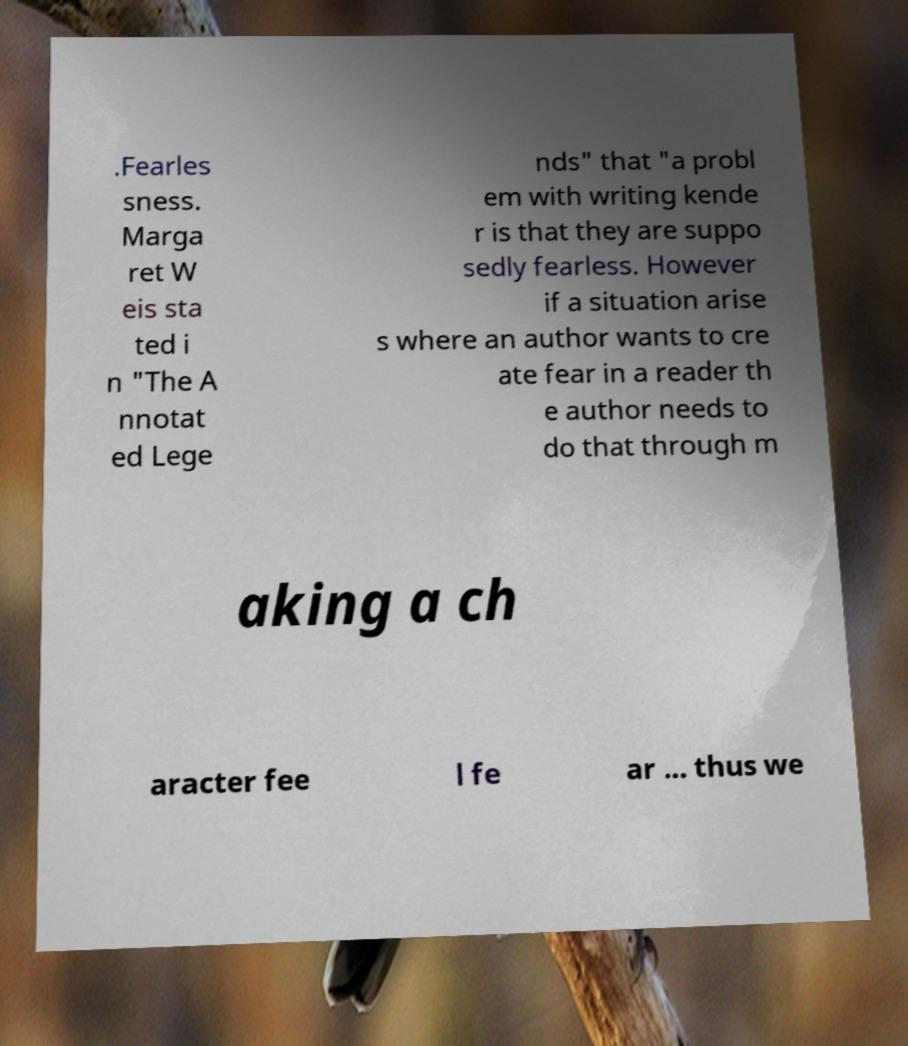For documentation purposes, I need the text within this image transcribed. Could you provide that? .Fearles sness. Marga ret W eis sta ted i n "The A nnotat ed Lege nds" that "a probl em with writing kende r is that they are suppo sedly fearless. However if a situation arise s where an author wants to cre ate fear in a reader th e author needs to do that through m aking a ch aracter fee l fe ar ... thus we 